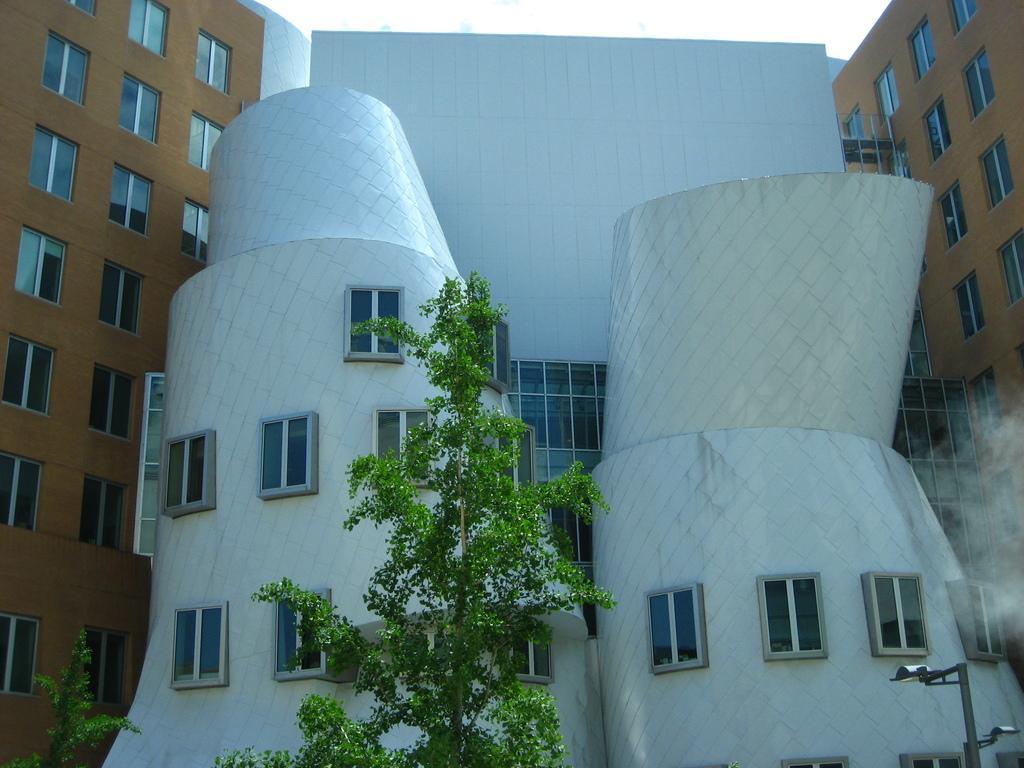Describe this image in one or two sentences. In this image there are some buildings, at the bottom there are trees and pole. 